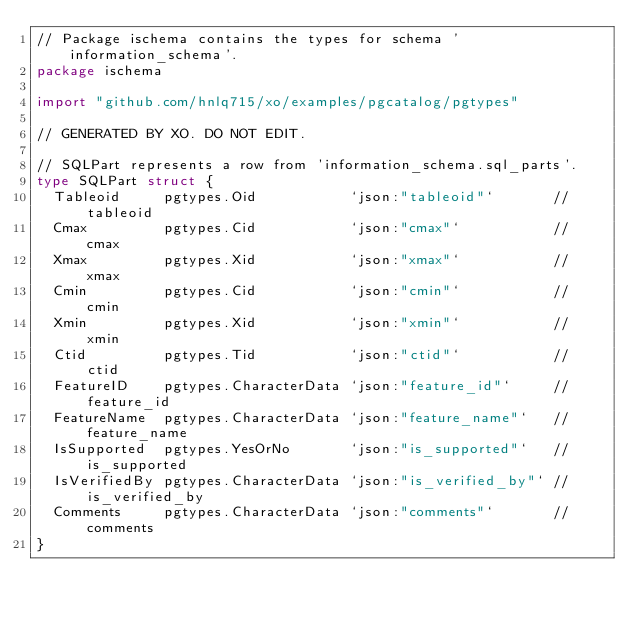Convert code to text. <code><loc_0><loc_0><loc_500><loc_500><_Go_>// Package ischema contains the types for schema 'information_schema'.
package ischema

import "github.com/hnlq715/xo/examples/pgcatalog/pgtypes"

// GENERATED BY XO. DO NOT EDIT.

// SQLPart represents a row from 'information_schema.sql_parts'.
type SQLPart struct {
	Tableoid     pgtypes.Oid           `json:"tableoid"`       // tableoid
	Cmax         pgtypes.Cid           `json:"cmax"`           // cmax
	Xmax         pgtypes.Xid           `json:"xmax"`           // xmax
	Cmin         pgtypes.Cid           `json:"cmin"`           // cmin
	Xmin         pgtypes.Xid           `json:"xmin"`           // xmin
	Ctid         pgtypes.Tid           `json:"ctid"`           // ctid
	FeatureID    pgtypes.CharacterData `json:"feature_id"`     // feature_id
	FeatureName  pgtypes.CharacterData `json:"feature_name"`   // feature_name
	IsSupported  pgtypes.YesOrNo       `json:"is_supported"`   // is_supported
	IsVerifiedBy pgtypes.CharacterData `json:"is_verified_by"` // is_verified_by
	Comments     pgtypes.CharacterData `json:"comments"`       // comments
}
</code> 